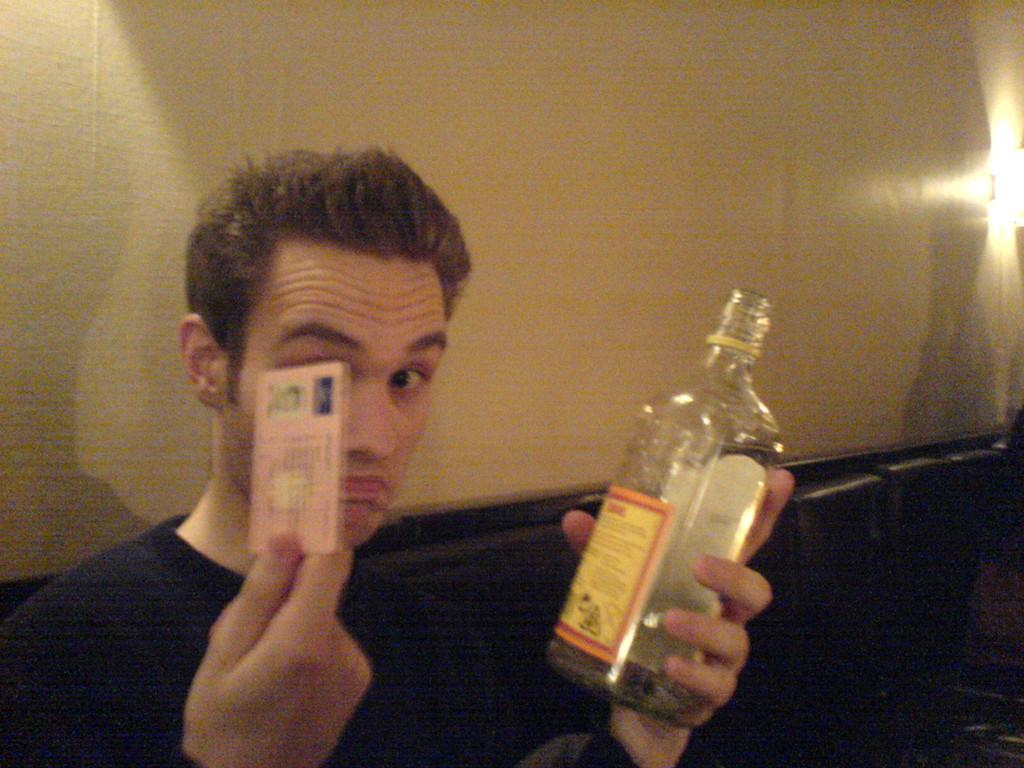Who is the main subject in the picture? There is a man in the picture. What is the man wearing? The man is wearing a black shirt. What is the man doing in the picture? The man is sitting on a sofa. What objects is the man holding in his hands? The man is holding a card in his right hand and a bottle in his left hand. What type of bridge can be seen in the background of the image? There is no bridge visible in the image; it only shows a man sitting on a sofa holding a card and a bottle. 